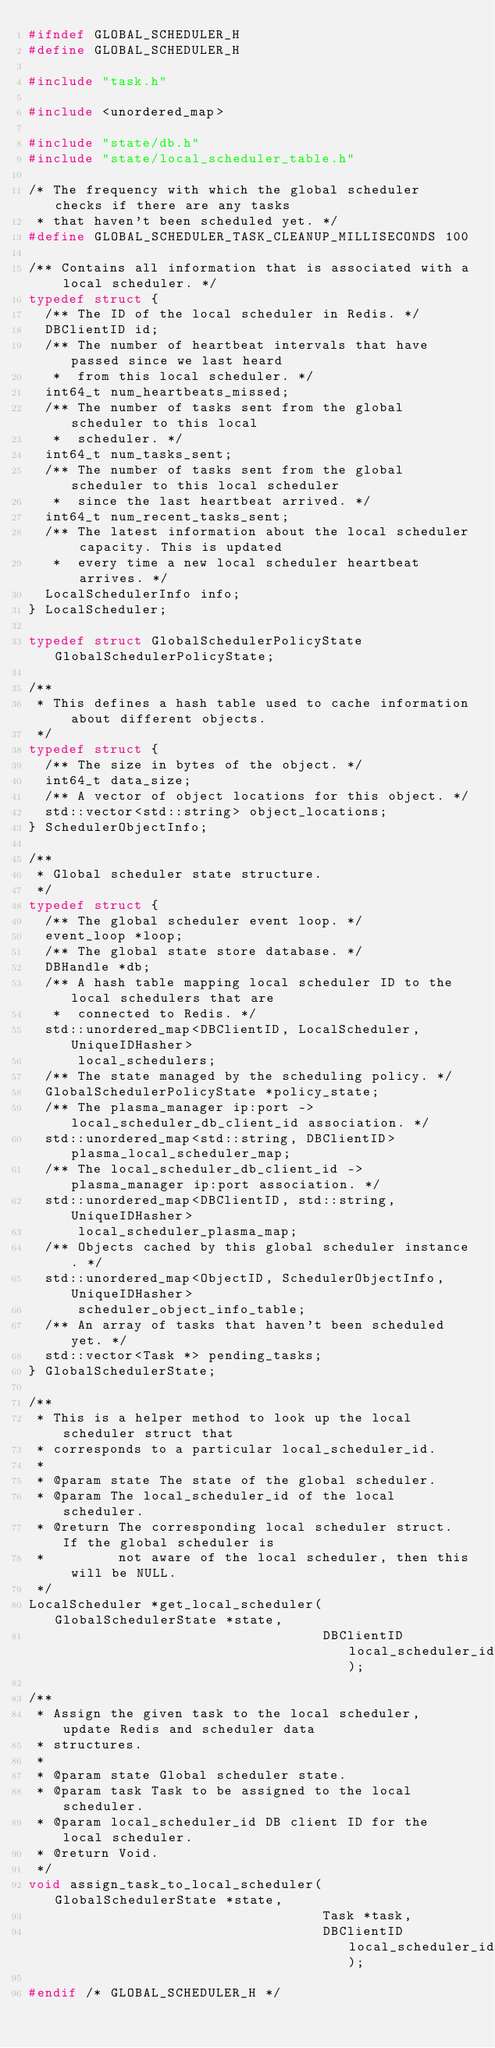Convert code to text. <code><loc_0><loc_0><loc_500><loc_500><_C_>#ifndef GLOBAL_SCHEDULER_H
#define GLOBAL_SCHEDULER_H

#include "task.h"

#include <unordered_map>

#include "state/db.h"
#include "state/local_scheduler_table.h"

/* The frequency with which the global scheduler checks if there are any tasks
 * that haven't been scheduled yet. */
#define GLOBAL_SCHEDULER_TASK_CLEANUP_MILLISECONDS 100

/** Contains all information that is associated with a local scheduler. */
typedef struct {
  /** The ID of the local scheduler in Redis. */
  DBClientID id;
  /** The number of heartbeat intervals that have passed since we last heard
   *  from this local scheduler. */
  int64_t num_heartbeats_missed;
  /** The number of tasks sent from the global scheduler to this local
   *  scheduler. */
  int64_t num_tasks_sent;
  /** The number of tasks sent from the global scheduler to this local scheduler
   *  since the last heartbeat arrived. */
  int64_t num_recent_tasks_sent;
  /** The latest information about the local scheduler capacity. This is updated
   *  every time a new local scheduler heartbeat arrives. */
  LocalSchedulerInfo info;
} LocalScheduler;

typedef struct GlobalSchedulerPolicyState GlobalSchedulerPolicyState;

/**
 * This defines a hash table used to cache information about different objects.
 */
typedef struct {
  /** The size in bytes of the object. */
  int64_t data_size;
  /** A vector of object locations for this object. */
  std::vector<std::string> object_locations;
} SchedulerObjectInfo;

/**
 * Global scheduler state structure.
 */
typedef struct {
  /** The global scheduler event loop. */
  event_loop *loop;
  /** The global state store database. */
  DBHandle *db;
  /** A hash table mapping local scheduler ID to the local schedulers that are
   *  connected to Redis. */
  std::unordered_map<DBClientID, LocalScheduler, UniqueIDHasher>
      local_schedulers;
  /** The state managed by the scheduling policy. */
  GlobalSchedulerPolicyState *policy_state;
  /** The plasma_manager ip:port -> local_scheduler_db_client_id association. */
  std::unordered_map<std::string, DBClientID> plasma_local_scheduler_map;
  /** The local_scheduler_db_client_id -> plasma_manager ip:port association. */
  std::unordered_map<DBClientID, std::string, UniqueIDHasher>
      local_scheduler_plasma_map;
  /** Objects cached by this global scheduler instance. */
  std::unordered_map<ObjectID, SchedulerObjectInfo, UniqueIDHasher>
      scheduler_object_info_table;
  /** An array of tasks that haven't been scheduled yet. */
  std::vector<Task *> pending_tasks;
} GlobalSchedulerState;

/**
 * This is a helper method to look up the local scheduler struct that
 * corresponds to a particular local_scheduler_id.
 *
 * @param state The state of the global scheduler.
 * @param The local_scheduler_id of the local scheduler.
 * @return The corresponding local scheduler struct. If the global scheduler is
 *         not aware of the local scheduler, then this will be NULL.
 */
LocalScheduler *get_local_scheduler(GlobalSchedulerState *state,
                                    DBClientID local_scheduler_id);

/**
 * Assign the given task to the local scheduler, update Redis and scheduler data
 * structures.
 *
 * @param state Global scheduler state.
 * @param task Task to be assigned to the local scheduler.
 * @param local_scheduler_id DB client ID for the local scheduler.
 * @return Void.
 */
void assign_task_to_local_scheduler(GlobalSchedulerState *state,
                                    Task *task,
                                    DBClientID local_scheduler_id);

#endif /* GLOBAL_SCHEDULER_H */
</code> 